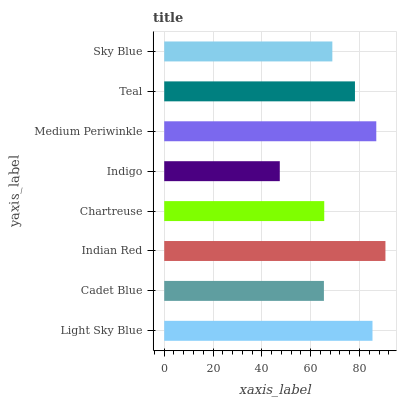Is Indigo the minimum?
Answer yes or no. Yes. Is Indian Red the maximum?
Answer yes or no. Yes. Is Cadet Blue the minimum?
Answer yes or no. No. Is Cadet Blue the maximum?
Answer yes or no. No. Is Light Sky Blue greater than Cadet Blue?
Answer yes or no. Yes. Is Cadet Blue less than Light Sky Blue?
Answer yes or no. Yes. Is Cadet Blue greater than Light Sky Blue?
Answer yes or no. No. Is Light Sky Blue less than Cadet Blue?
Answer yes or no. No. Is Teal the high median?
Answer yes or no. Yes. Is Sky Blue the low median?
Answer yes or no. Yes. Is Chartreuse the high median?
Answer yes or no. No. Is Medium Periwinkle the low median?
Answer yes or no. No. 